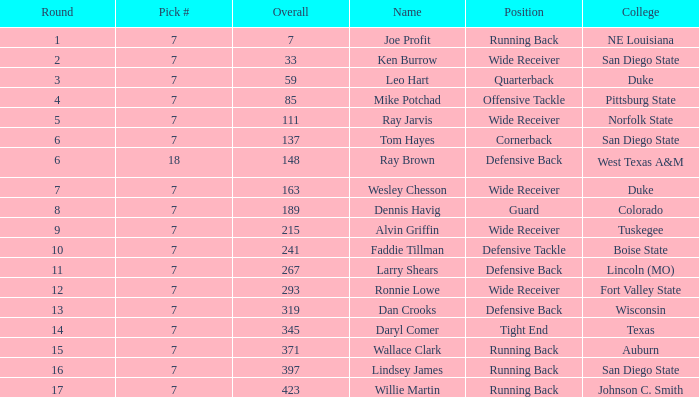What numbered pick was the player from texas? 1.0. 